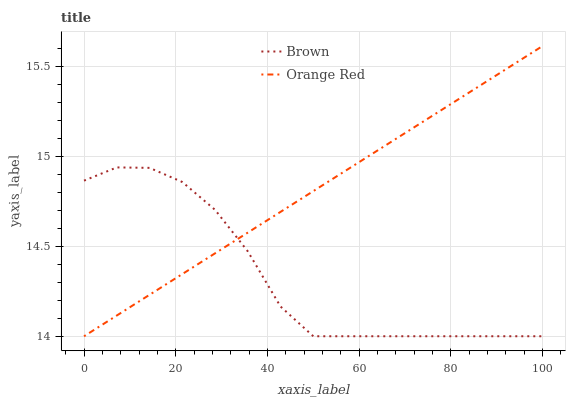Does Brown have the minimum area under the curve?
Answer yes or no. Yes. Does Orange Red have the maximum area under the curve?
Answer yes or no. Yes. Does Orange Red have the minimum area under the curve?
Answer yes or no. No. Is Orange Red the smoothest?
Answer yes or no. Yes. Is Brown the roughest?
Answer yes or no. Yes. Is Orange Red the roughest?
Answer yes or no. No. Does Brown have the lowest value?
Answer yes or no. Yes. Does Orange Red have the highest value?
Answer yes or no. Yes. Does Orange Red intersect Brown?
Answer yes or no. Yes. Is Orange Red less than Brown?
Answer yes or no. No. Is Orange Red greater than Brown?
Answer yes or no. No. 